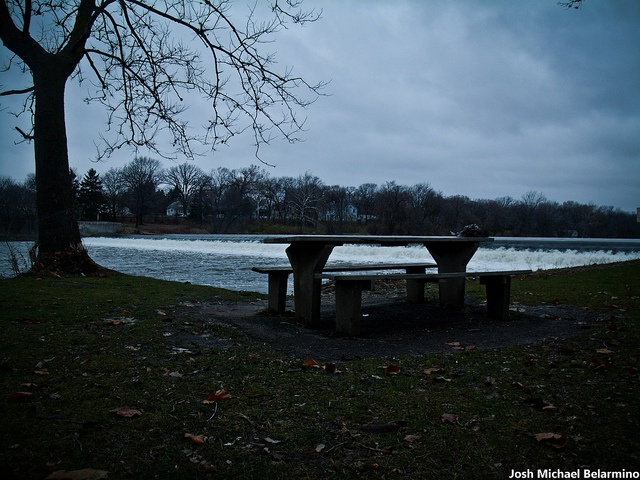Describe the objects in this image and their specific colors. I can see bench in black, lightblue, darkgray, and gray tones and dining table in black, purple, blue, and gray tones in this image. 